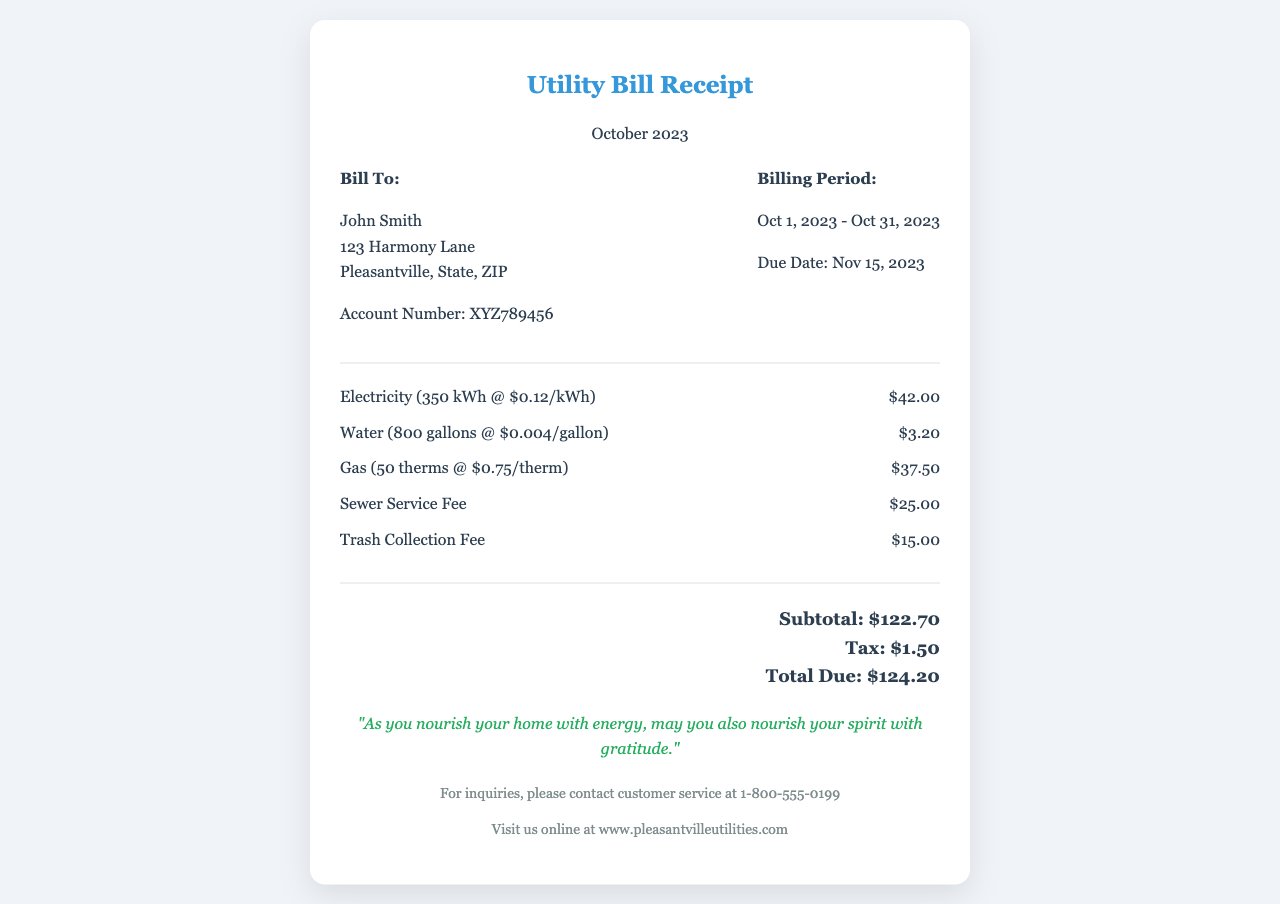What is the total due for the utility bill? The total due is clearly stated at the bottom of the receipt, which is calculated from the subtotal and tax.
Answer: $124.20 Who is the bill addressed to? The receipt specifies the name of the person the bill is addressed to in the "Bill To" section.
Answer: John Smith What is the billing period for this utility bill? The billing period is mentioned in the "Billing Period" section of the receipt, indicating the start and end dates.
Answer: Oct 1, 2023 - Oct 31, 2023 How much was charged for electricity? The receipt includes a breakdown of charges, and the amount for electricity is listed under the respective category.
Answer: $42.00 What is the due date for the payment? The due date is specified in the "Billing Period" section of the receipt.
Answer: Nov 15, 2023 What is the sewage service fee? The receipt contains a breakdown of additional charges, and the sewage service fee is listed as one of them.
Answer: $25.00 How many gallons of water were used according to the bill? The number of gallons used is included in the charge item for water on the receipt.
Answer: 800 gallons What inspirational quote is included in the document? There is a specific quote at the bottom that reflects a spiritual sentiment, located in the "spiritual-quote" section.
Answer: "As you nourish your home with energy, may you also nourish your spirit with gratitude." What is the tax amount included in the total? The tax amount is specifically detailed in the total section of the receipt, which adds to the total due.
Answer: $1.50 